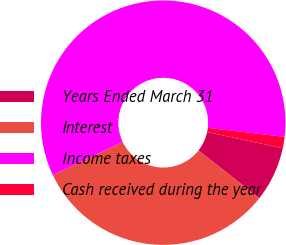Convert chart. <chart><loc_0><loc_0><loc_500><loc_500><pie_chart><fcel>Years Ended March 31<fcel>Interest<fcel>Income taxes<fcel>Cash received during the year<nl><fcel>7.25%<fcel>32.32%<fcel>58.91%<fcel>1.51%<nl></chart> 